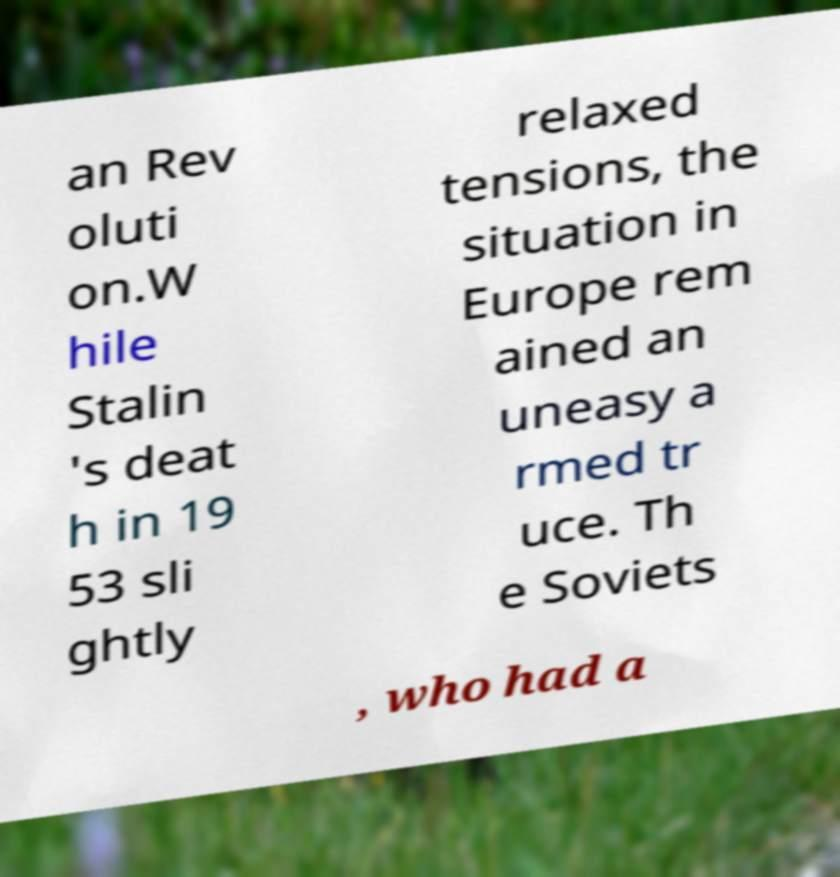What messages or text are displayed in this image? I need them in a readable, typed format. an Rev oluti on.W hile Stalin 's deat h in 19 53 sli ghtly relaxed tensions, the situation in Europe rem ained an uneasy a rmed tr uce. Th e Soviets , who had a 